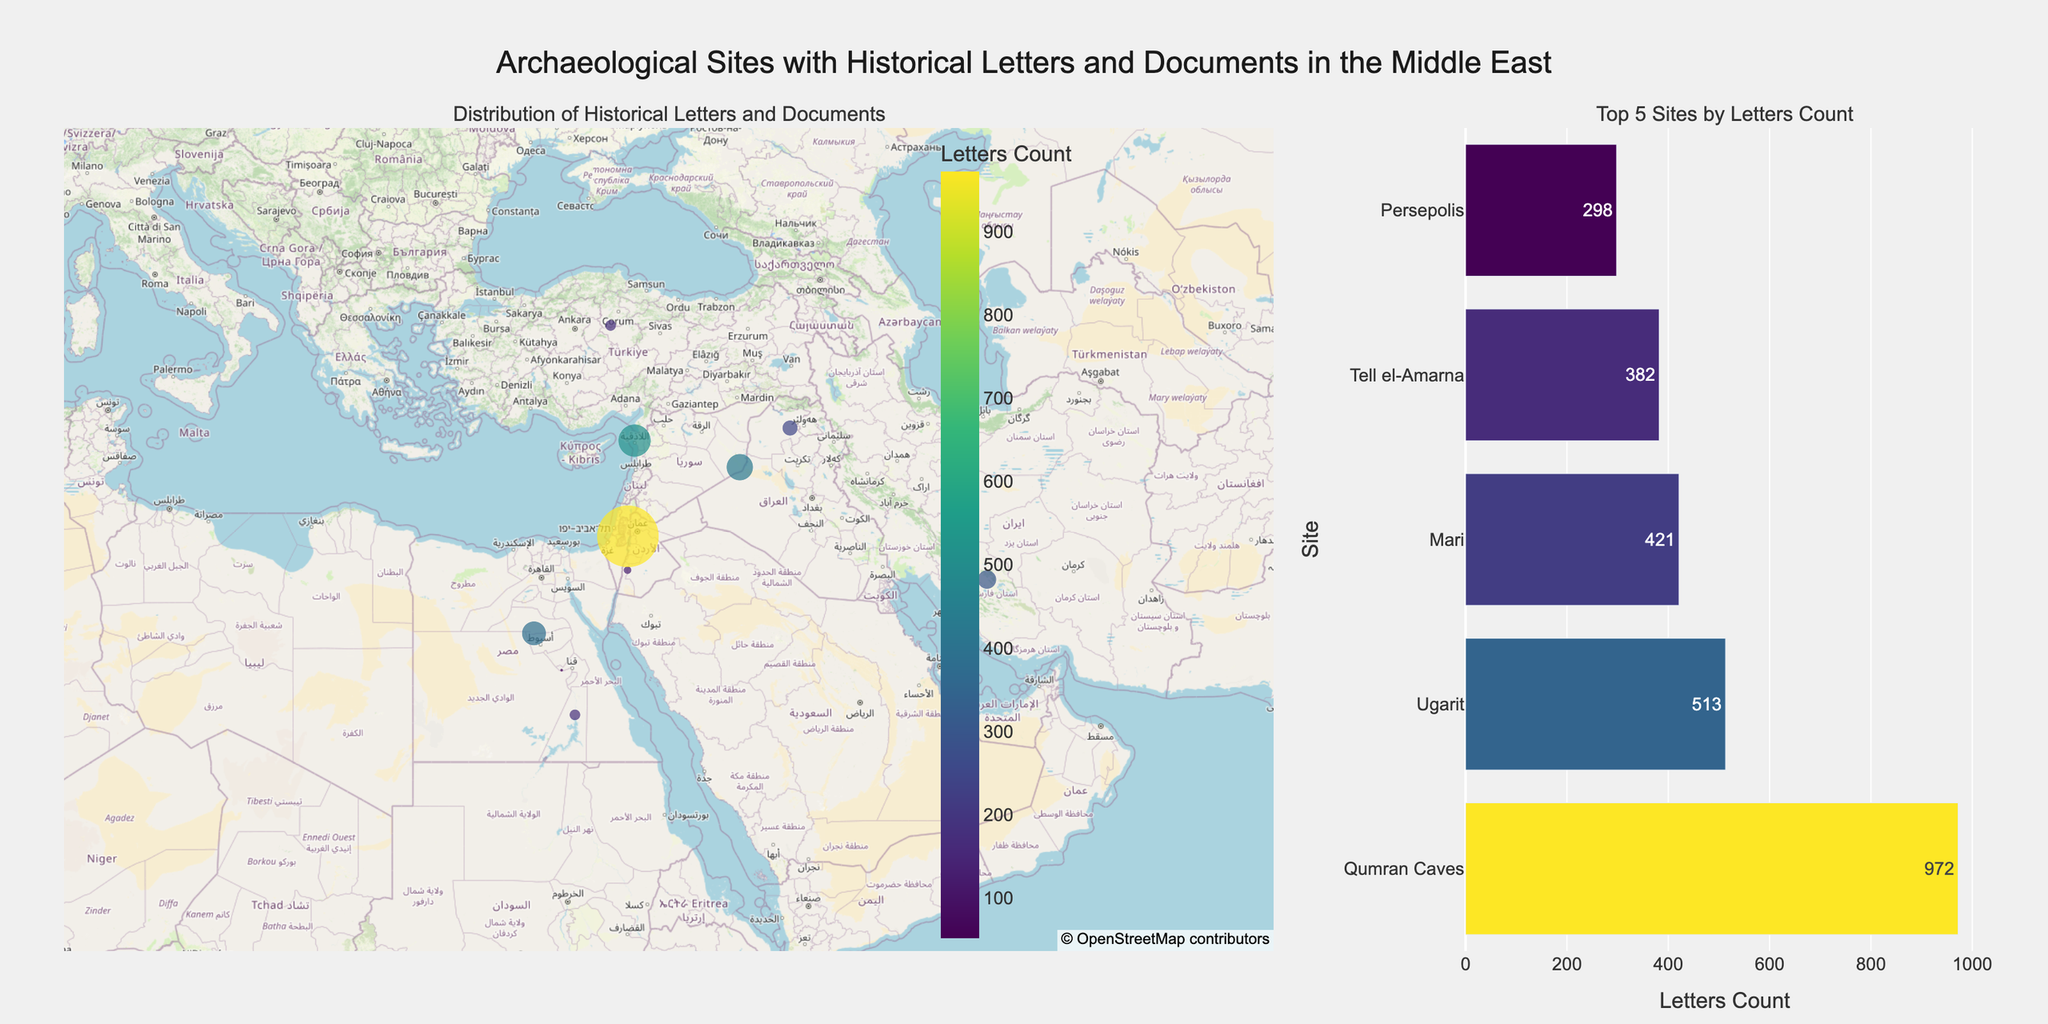How many archaeological sites are displayed on the map? Count the number of markers on the map, which corresponds to the number of data points. Each data point represents an archaeological site.
Answer: 10 Which site has the highest count of discovered letters? The bar chart on the right shows the top 5 sites by letters count. By observing the length of the bars, "Qumran Caves" has the longest bar, indicating it has the highest count of discovered letters.
Answer: Qumran Caves What is the total count of letters discovered across all sites? Sum up the 'Letters_Count' values for all sites (127 + 972 + 382 + 245 + 176 + 513 + 298 + 175 + 52 + 421).
Answer: 3361 How many sites are there in Egypt? Look at the geographical locations on the map and the provided data, count the sites with 'Country' as 'Egypt'. These include Tell el-Amarna, Elephantine, and Nag Hammadi.
Answer: 3 Which site has the smallest count of discovered letters, and what is that count? By observing the map and the provided data, it is evident that Nag Hammadi has the smallest marker size and lowest count of letters (52).
Answer: Nag Hammadi, 52 Compare the counts of letters discovered in Mari and Nimrud. Mari has 421 letters, while Nimrud has 245 letters. By comparing these values, Mari has more letters discovered than Nimrud.
Answer: Mari has more What is the average number of letters discovered per site for the top 5 sites by letters count? Sum the letters count for the top 5 sites (972 + 513 + 421 + 382 + 298) and divide by 5. (972 + 513 + 421 + 382 + 298 = 2586, then 2586 / 5 = 517.2).
Answer: 517.2 Which countries have multiple sites displayed on the map? By observing the data and the map, Egypt and Syria each have more than one site (Egypt: Tell el-Amarna, Elephantine, Nag Hammadi; Syria: Ugarit, Mari).
Answer: Egypt and Syria Compare the historical periods of letters found at Petra and Ugarit. Which is earlier? Petra's letters are from the 1st century BCE - 2nd century CE, while Ugarit's letters are from the 14th-12th century BCE. Since BCE dates are earlier than CE dates, Ugarit's historical period is earlier.
Answer: Ugarit What is the median count of letters discovered in all sites? Arrange the 'Letters_Count' in ascending order (52, 127, 175, 176, 245, 298, 382, 421, 513, 972). As there are 10 data points, the median is the average of the 5th and 6th values: (245 + 298) / 2 = 271.5.
Answer: 271.5 